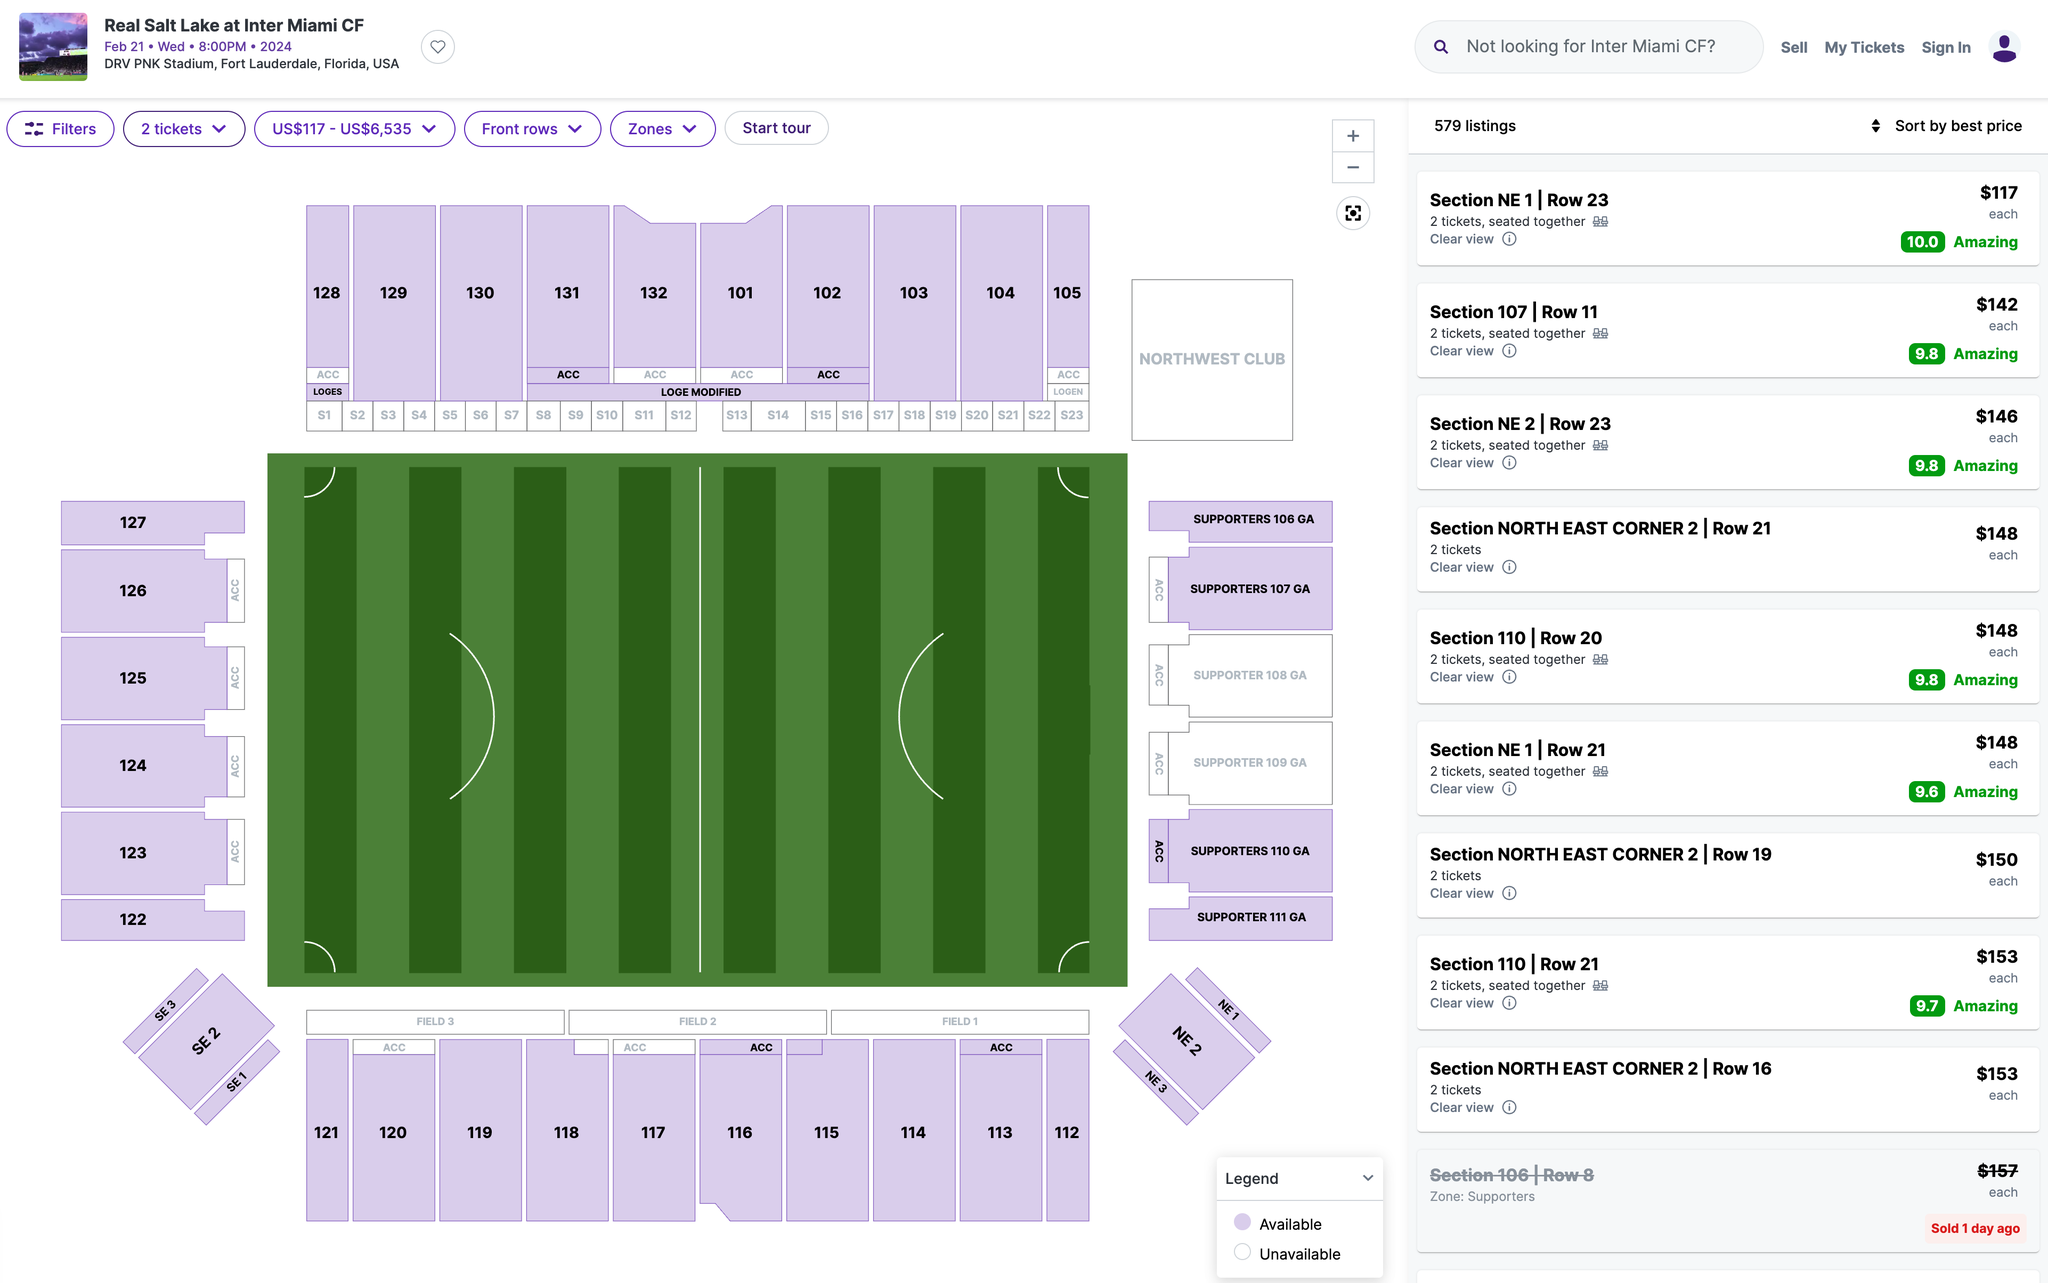Which section's ticket would you recommend I purchase? I recommend purchasing tickets in Section 107. This section is located on the west side of the stadium, and it offers a great view of the field. Additionally, this section is relatively close to the action, so you will be able to see the players up close. 